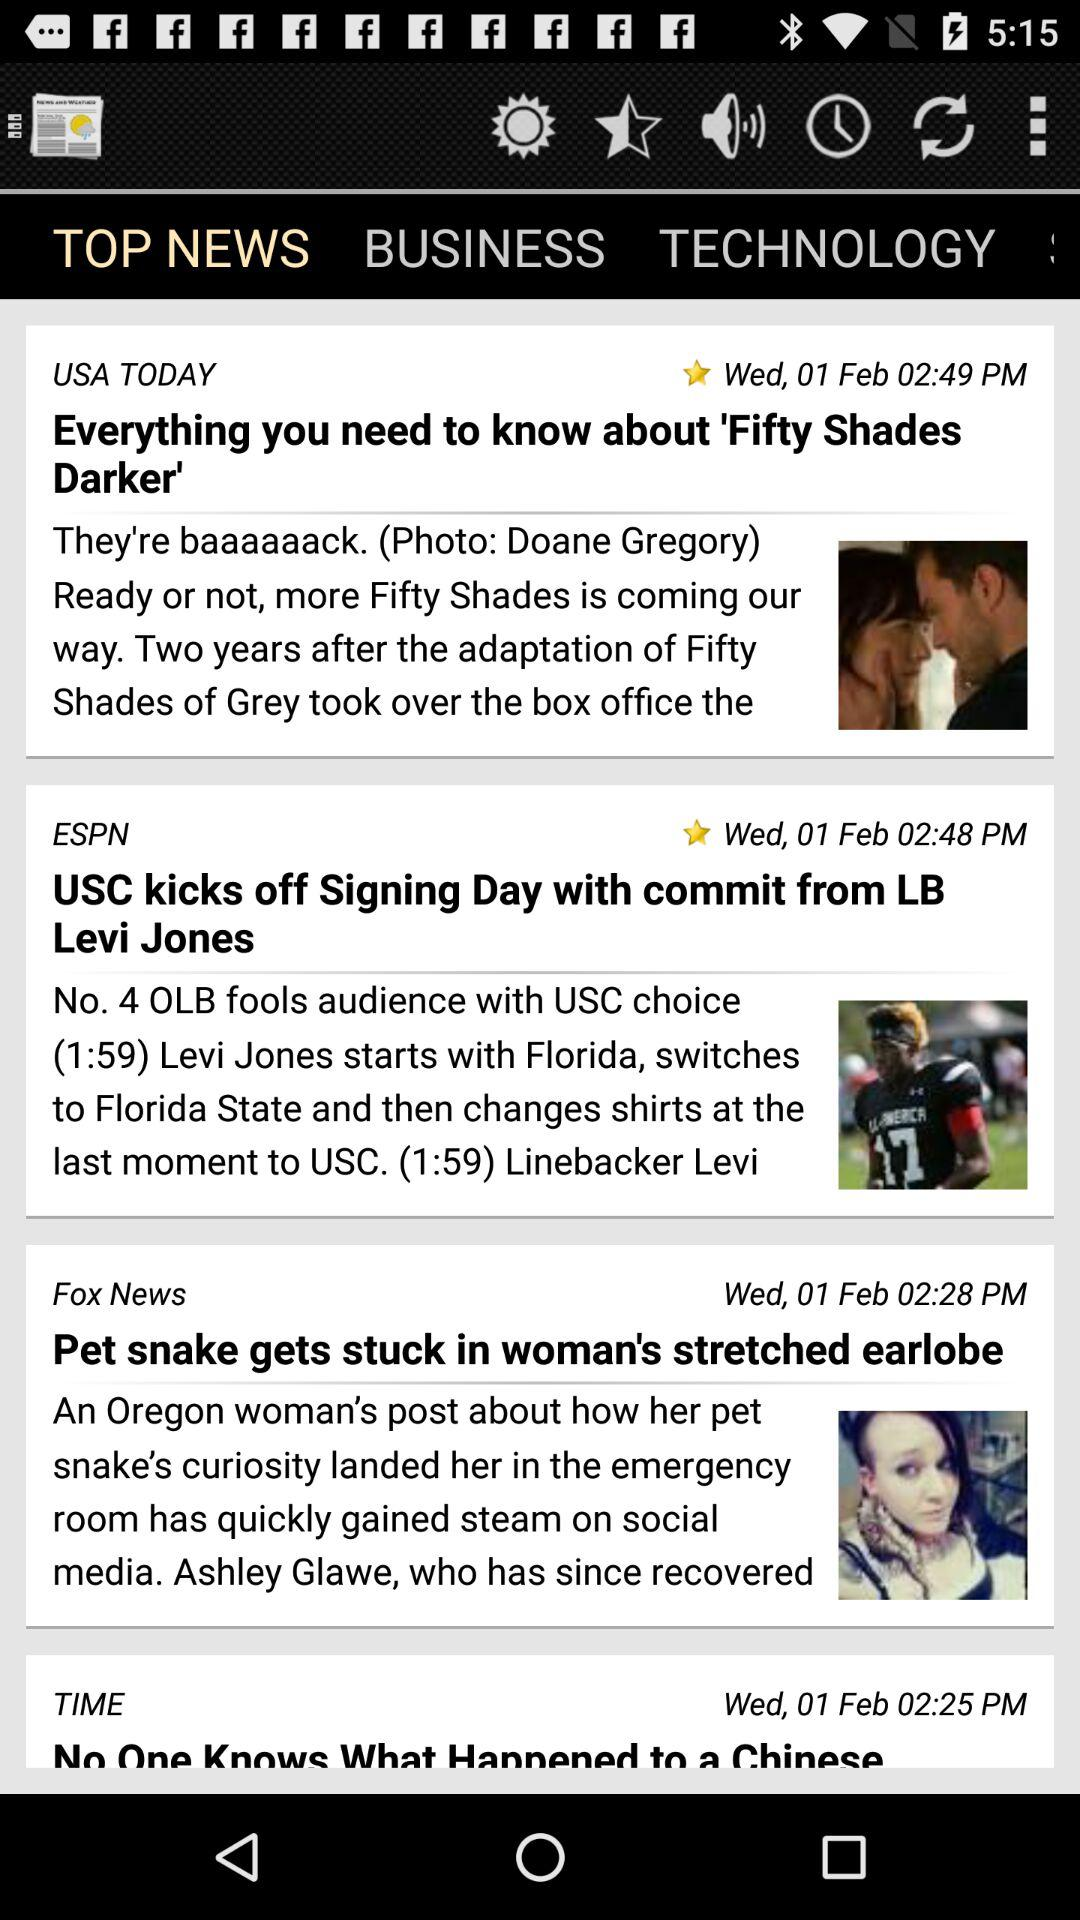At what time was the news "Everything you need to know about 'Fifty Shades Darker'" updated? The news was updated at 02:49 P.M. 